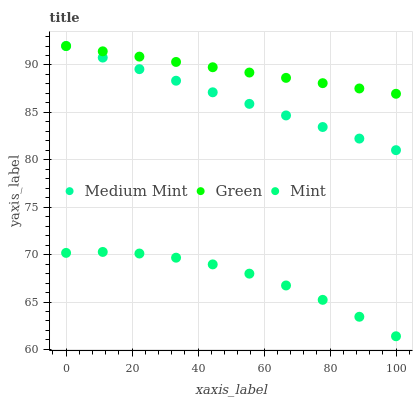Does Mint have the minimum area under the curve?
Answer yes or no. Yes. Does Green have the maximum area under the curve?
Answer yes or no. Yes. Does Green have the minimum area under the curve?
Answer yes or no. No. Does Mint have the maximum area under the curve?
Answer yes or no. No. Is Medium Mint the smoothest?
Answer yes or no. Yes. Is Mint the roughest?
Answer yes or no. Yes. Is Green the smoothest?
Answer yes or no. No. Is Green the roughest?
Answer yes or no. No. Does Mint have the lowest value?
Answer yes or no. Yes. Does Green have the lowest value?
Answer yes or no. No. Does Green have the highest value?
Answer yes or no. Yes. Does Mint have the highest value?
Answer yes or no. No. Is Mint less than Medium Mint?
Answer yes or no. Yes. Is Green greater than Mint?
Answer yes or no. Yes. Does Medium Mint intersect Green?
Answer yes or no. Yes. Is Medium Mint less than Green?
Answer yes or no. No. Is Medium Mint greater than Green?
Answer yes or no. No. Does Mint intersect Medium Mint?
Answer yes or no. No. 